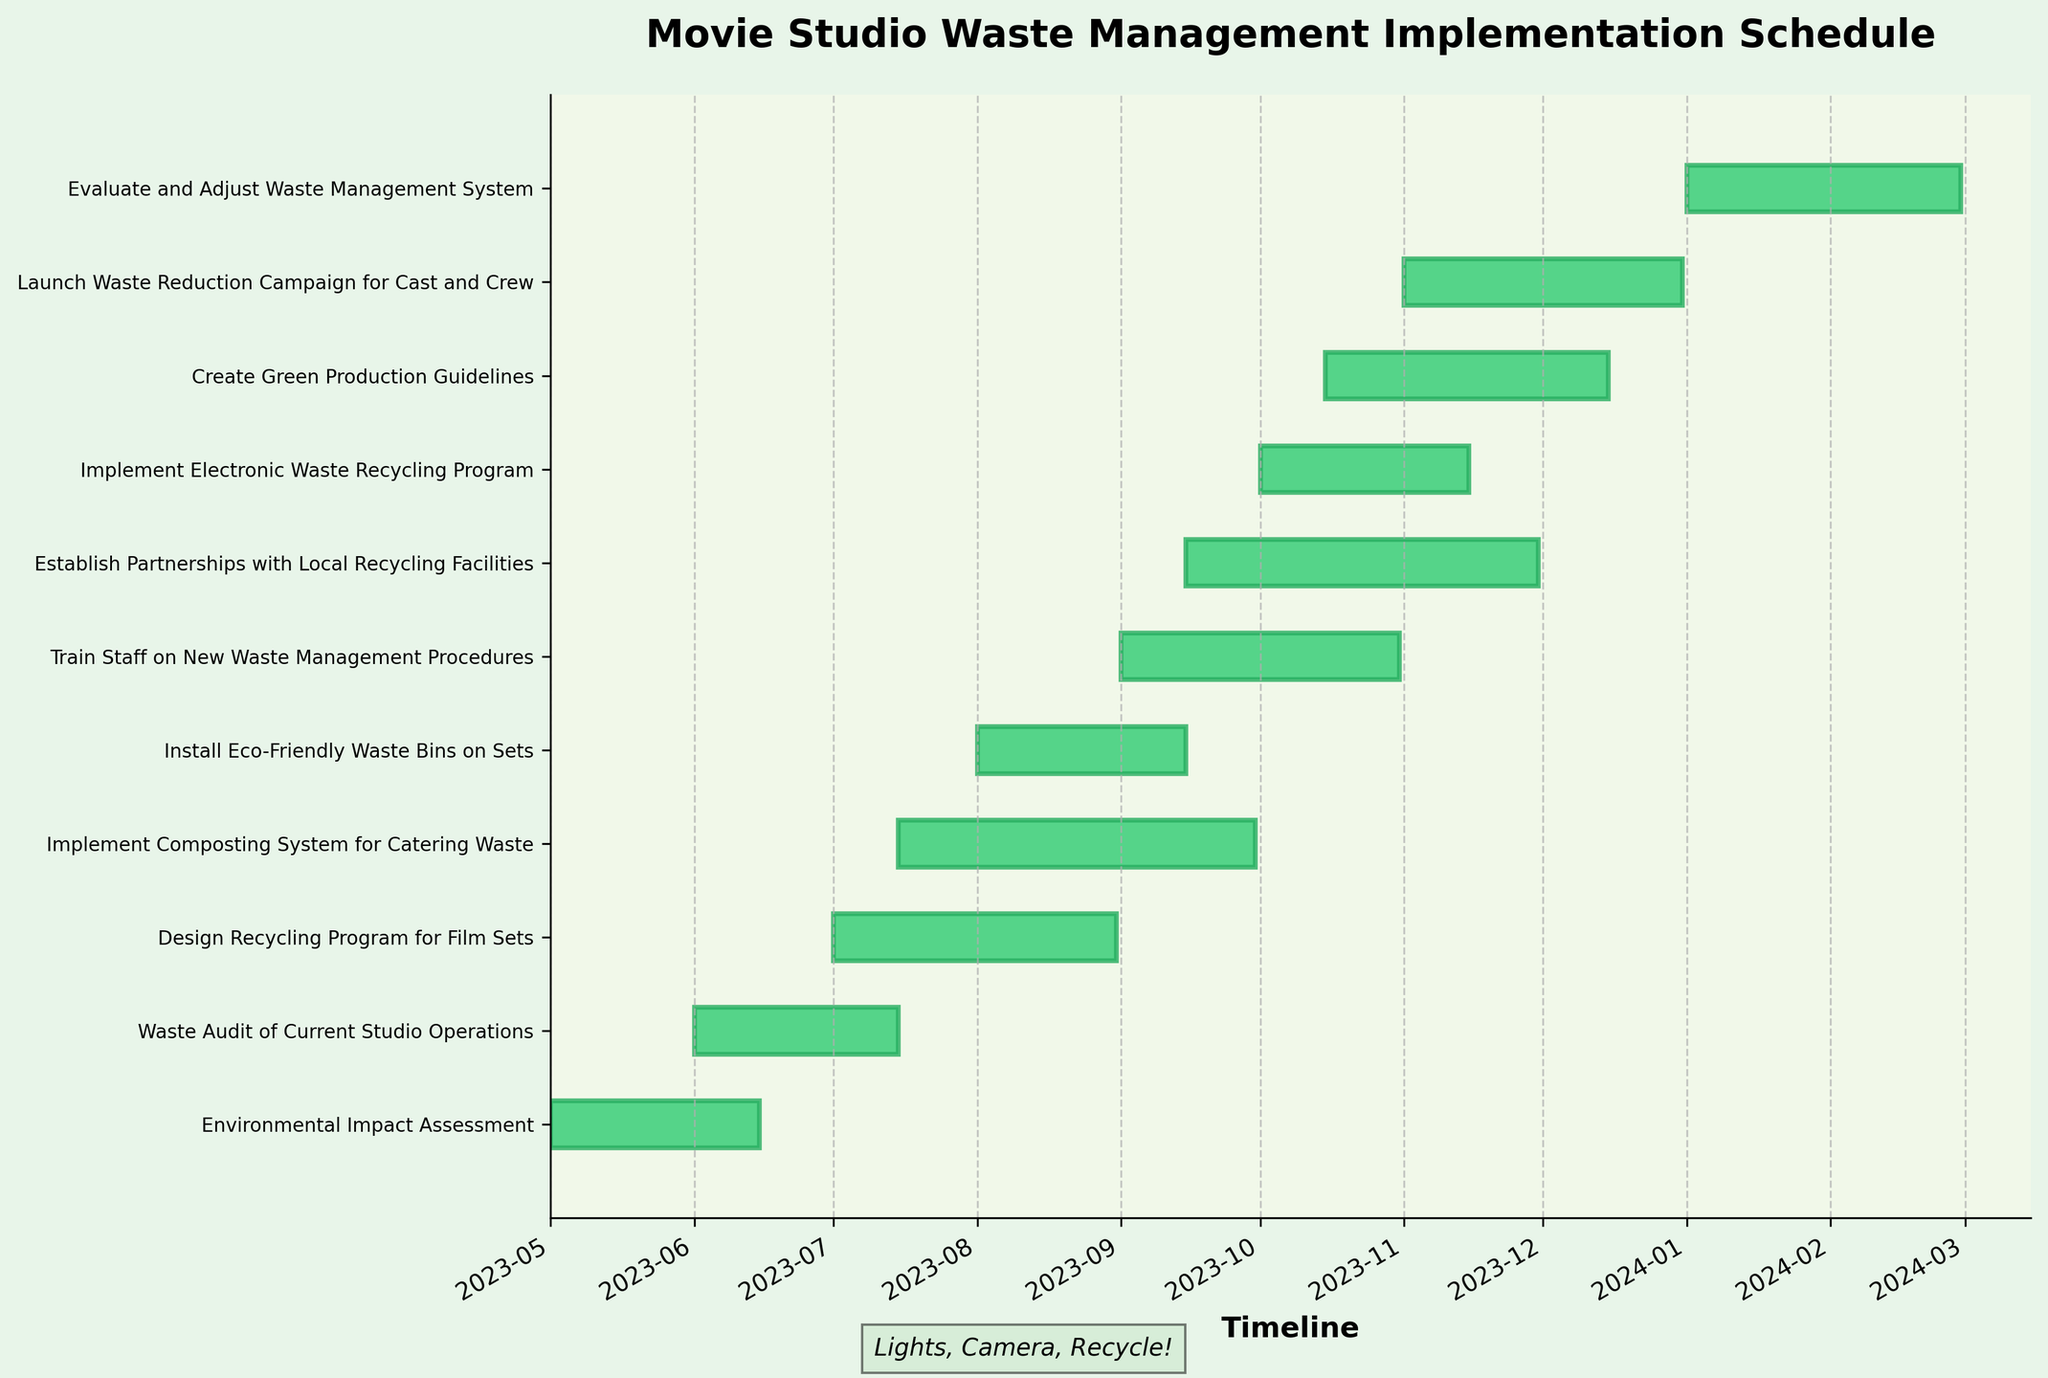What is the title of the Gantt chart? The title is typically found at the top of the Gantt chart. In this case, the title is centered and in bold font.
Answer: Movie Studio Waste Management Implementation Schedule When does the "Train Staff on New Waste Management Procedures" task start and end? The start and end dates for a task are indicated by the left and right ends of the respective bar in the Gantt chart. This task starts on 2023-09-01 and ends on 2023-10-31.
Answer: 2023-09-01 to 2023-10-31 Which task starts first and how long does it take to complete? Locate the task with the earliest start date by checking the leftmost bars. The "Environmental Impact Assessment" starts first on 2023-05-01, and it takes 45 days to complete (from 2023-05-01 to 2023-06-15).
Answer: Environmental Impact Assessment, 45 days How many tasks are scheduled to end within November 2023? Check the Gantt chart for any tasks whose bars end within the month of November 2023. "Establish Partnerships with Local Recycling Facilities" (2023-11-30), "Implement Electronic Waste Recycling Program" (2023-11-15), and "Create Green Production Guidelines" (2023-12-15 fall within this month. So there are three tasks.
Answer: 3 tasks Which task has the longest duration, and how long is it? Compare the length of the bars representing each task to find the longest one. The "Train Staff on New Waste Management Procedures" has the longest duration, spanning from 2023-09-01 to 2023-10-31, which is 61 days.
Answer: Train Staff on New Waste Management Procedures, 61 days What is the time gap between the end of "Waste Audit of Current Studio Operations" and the start of "Design Recycling Program for Film Sets"? "Waste Audit of Current Studio Operations" ends on 2023-07-15, and "Design Recycling Program for Film Sets" starts on 2023-07-01. Therefore, there is a negative overlap of 14 days, indicating an overlap.
Answer: -14 days Which two tasks overlap the most, and what is the overlap period? Identify the tasks that coincide the most by cross-referencing their start and end dates. "Design Recycling Program for Film Sets" (2023-07-01 to 2023-08-31) and "Implement Composting System for Catering Waste" (2023-07-15 to 2023-09-30) overlap by 47 days, which is the most significant overlap.
Answer: Design Recycling Program for Film Sets & Implement Composting System for Catering Waste, 47 days How many tasks need to be completed before the "Launch Waste Reduction Campaign for Cast and Crew" begins? Trace the preceding tasks on the Gantt chart to determine which tasks end before this one starts. The "Launch Waste Reduction Campaign for Cast and Crew" starts on 2023-11-01, by this time, the tasks that must be completed are: "Environmental Impact Assessment," "Waste Audit of Current Studio Operations," "Design Recycling Program for Film Sets," "Implement Composting System for Catering Waste," "Install Eco-Friendly Waste Bins on Sets," and "Train Staff on New Waste Management Procedures." There are six tasks in total.
Answer: 6 tasks When is the "Evaluate and Adjust Waste Management System" scheduled, and how long does it take? Check the task bar for "Evaluate and Adjust Waste Management System" to find its start and end dates. The task is scheduled from 2024-01-01 to 2024-02-29; hence, it takes 60 days.
Answer: 2024-01-01 to 2024-02-29, 60 days 